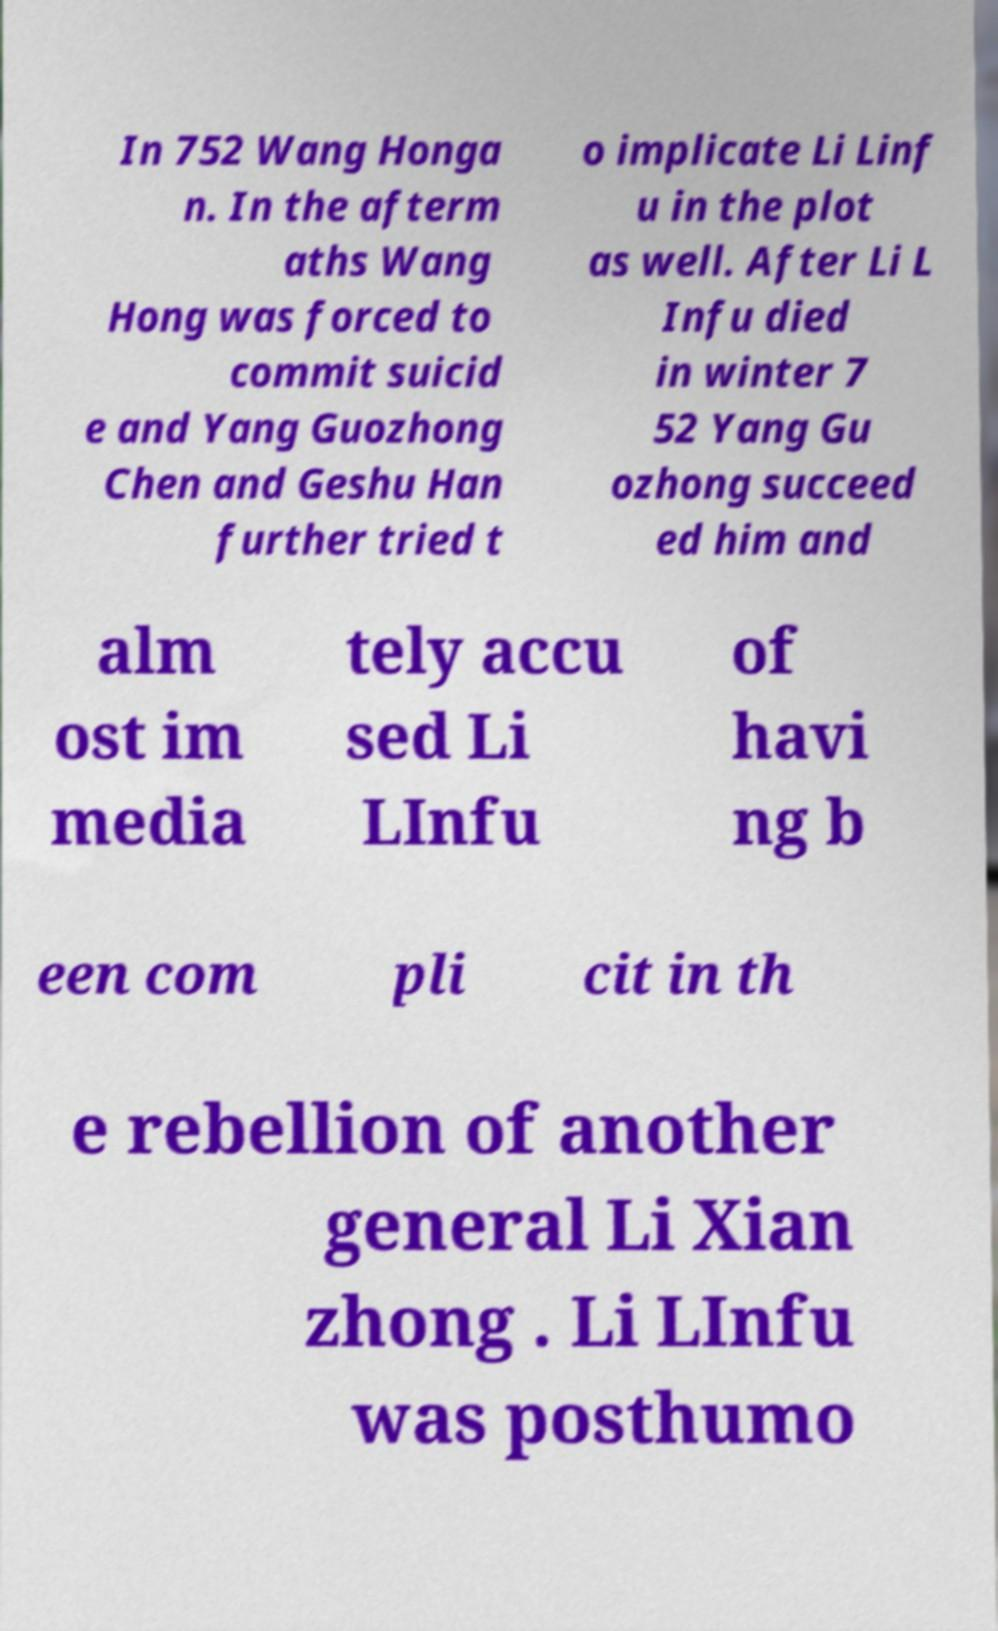There's text embedded in this image that I need extracted. Can you transcribe it verbatim? In 752 Wang Honga n. In the afterm aths Wang Hong was forced to commit suicid e and Yang Guozhong Chen and Geshu Han further tried t o implicate Li Linf u in the plot as well. After Li L Infu died in winter 7 52 Yang Gu ozhong succeed ed him and alm ost im media tely accu sed Li LInfu of havi ng b een com pli cit in th e rebellion of another general Li Xian zhong . Li LInfu was posthumo 